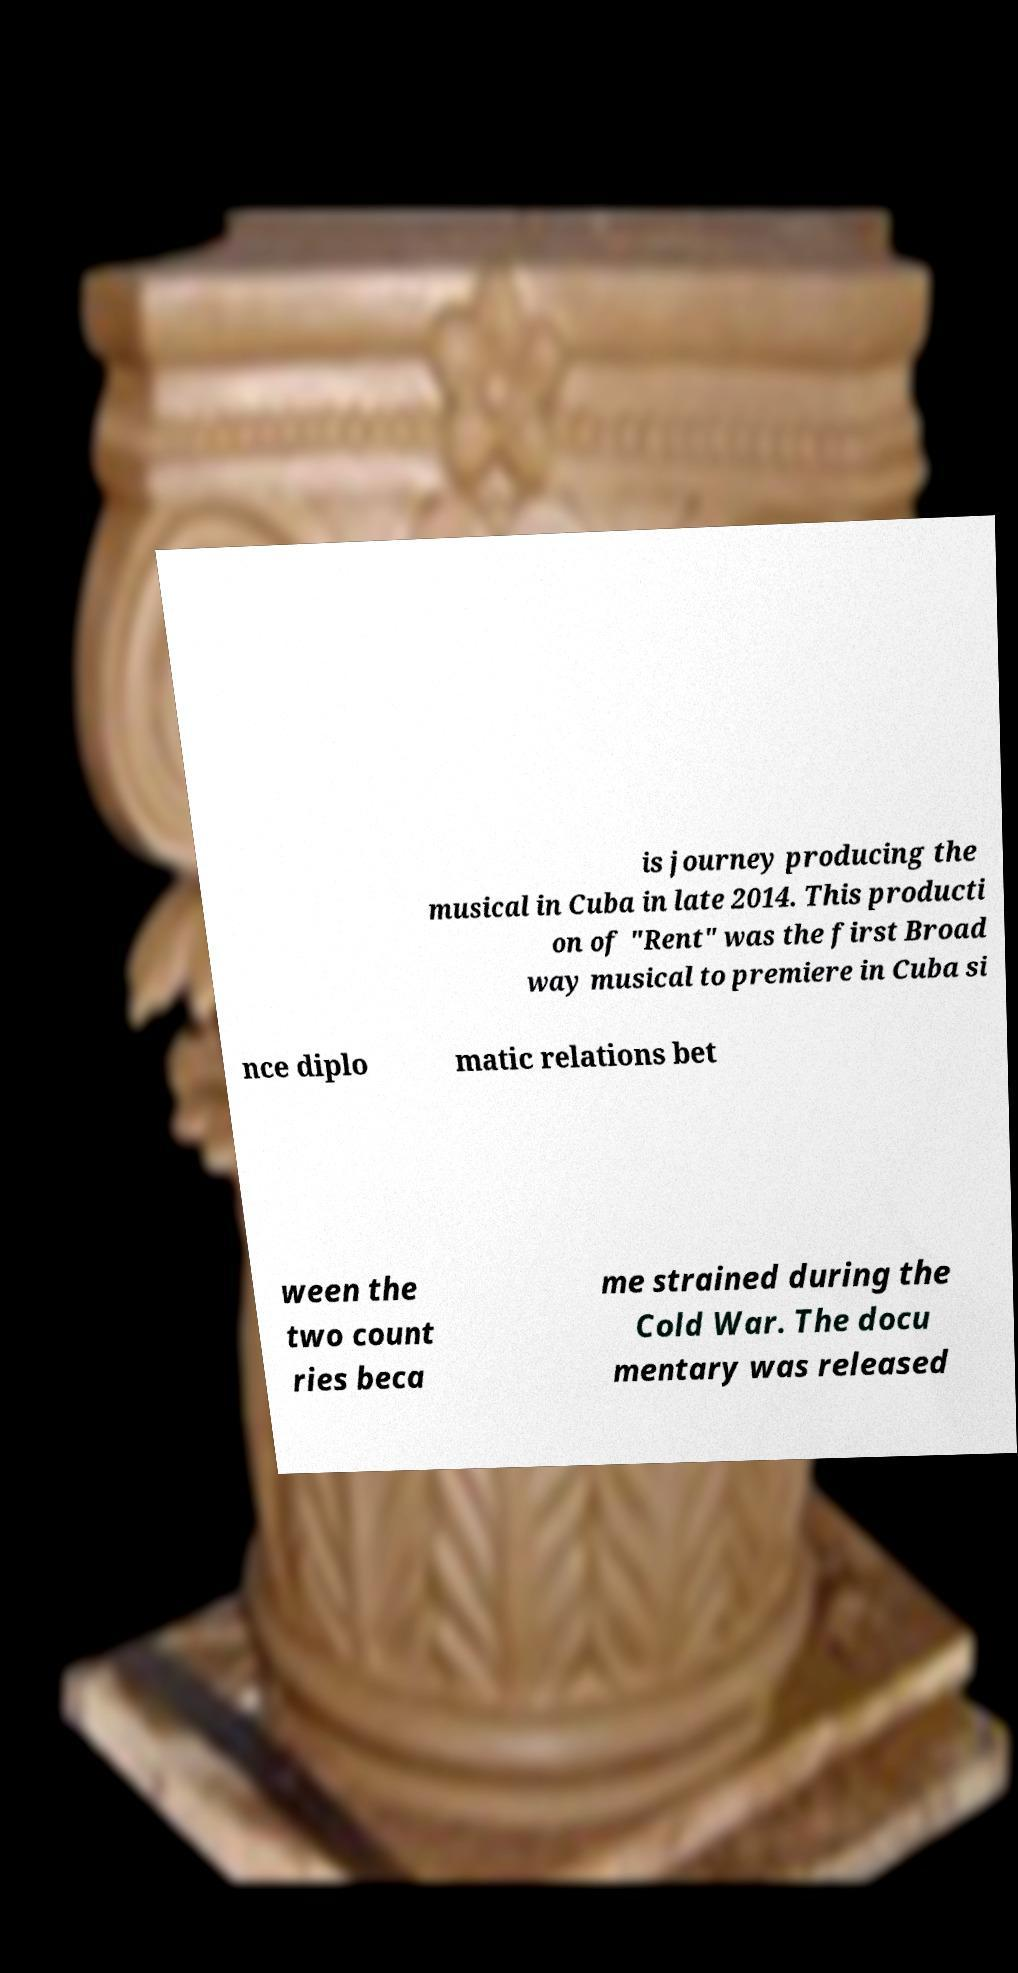Could you extract and type out the text from this image? is journey producing the musical in Cuba in late 2014. This producti on of "Rent" was the first Broad way musical to premiere in Cuba si nce diplo matic relations bet ween the two count ries beca me strained during the Cold War. The docu mentary was released 